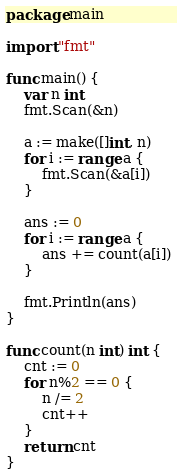<code> <loc_0><loc_0><loc_500><loc_500><_Go_>package main

import "fmt"

func main() {
	var n int
	fmt.Scan(&n)

	a := make([]int, n)
	for i := range a {
		fmt.Scan(&a[i])
	}

	ans := 0
	for i := range a {
		ans += count(a[i])
	}

	fmt.Println(ans)
}

func count(n int) int {
	cnt := 0
	for n%2 == 0 {
		n /= 2
		cnt++
	}
	return cnt
}</code> 